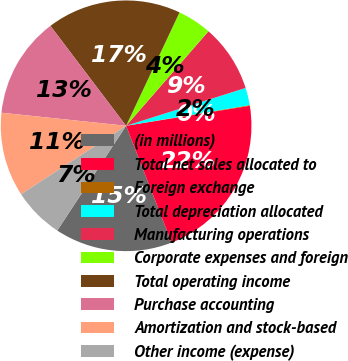Convert chart. <chart><loc_0><loc_0><loc_500><loc_500><pie_chart><fcel>(in millions)<fcel>Total net sales allocated to<fcel>Foreign exchange<fcel>Total depreciation allocated<fcel>Manufacturing operations<fcel>Corporate expenses and foreign<fcel>Total operating income<fcel>Purchase accounting<fcel>Amortization and stock-based<fcel>Other income (expense)<nl><fcel>15.17%<fcel>21.64%<fcel>0.09%<fcel>2.24%<fcel>8.71%<fcel>4.4%<fcel>17.33%<fcel>13.02%<fcel>10.86%<fcel>6.55%<nl></chart> 